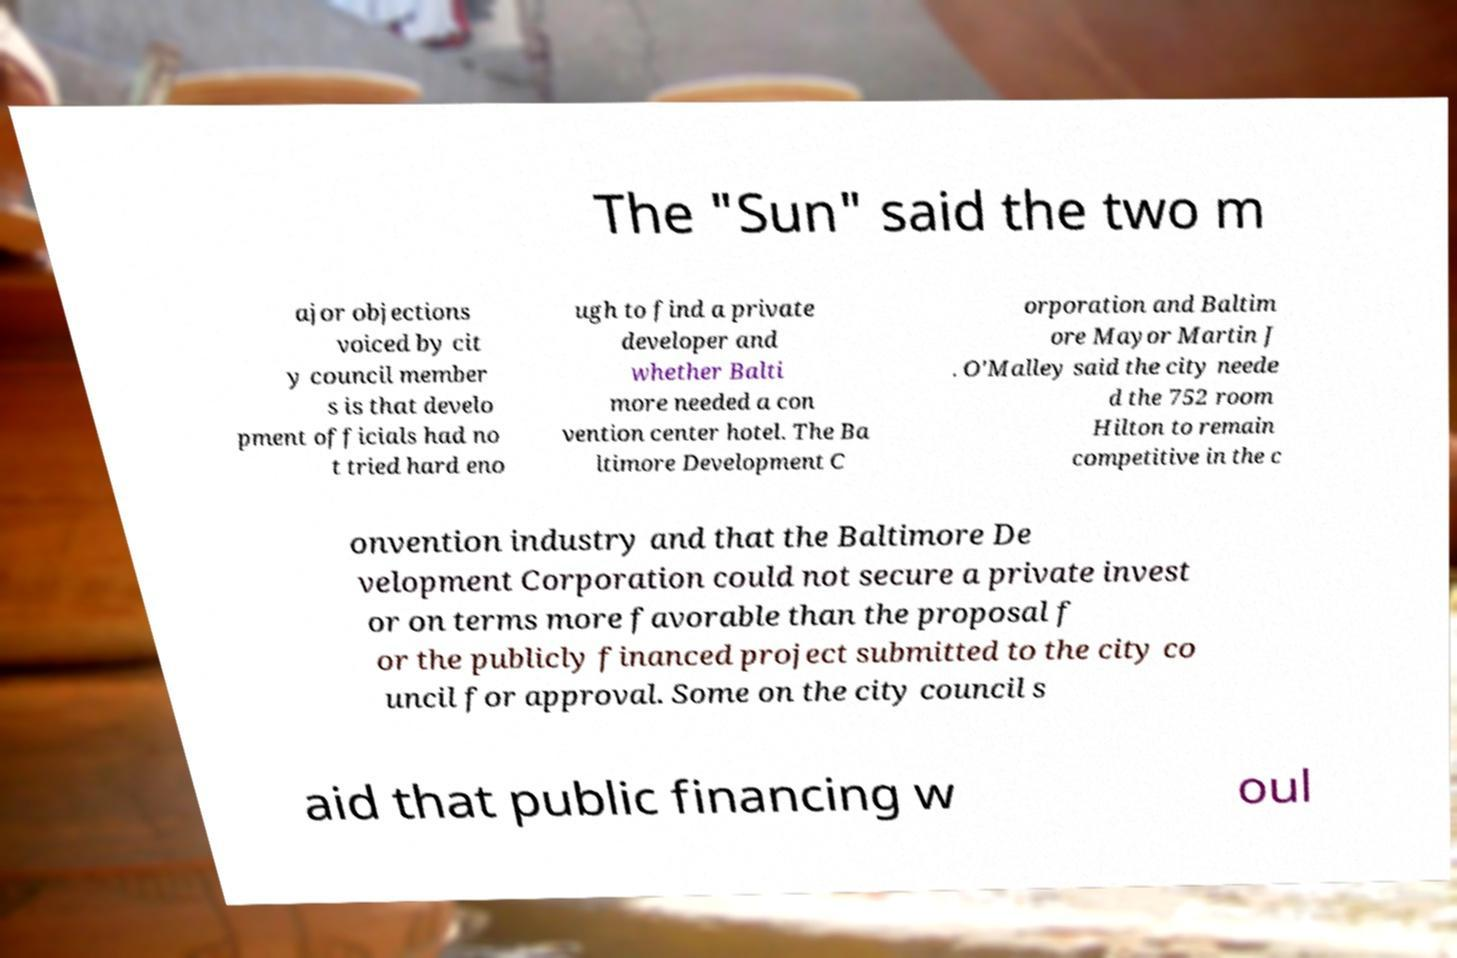Could you assist in decoding the text presented in this image and type it out clearly? The "Sun" said the two m ajor objections voiced by cit y council member s is that develo pment officials had no t tried hard eno ugh to find a private developer and whether Balti more needed a con vention center hotel. The Ba ltimore Development C orporation and Baltim ore Mayor Martin J . O'Malley said the city neede d the 752 room Hilton to remain competitive in the c onvention industry and that the Baltimore De velopment Corporation could not secure a private invest or on terms more favorable than the proposal f or the publicly financed project submitted to the city co uncil for approval. Some on the city council s aid that public financing w oul 